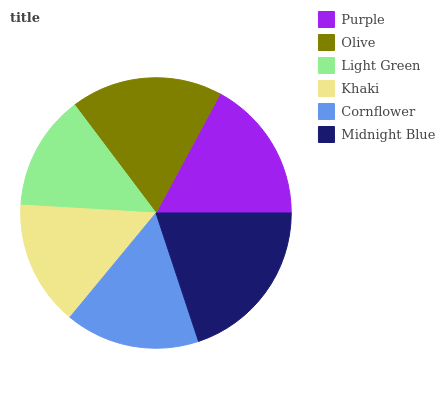Is Light Green the minimum?
Answer yes or no. Yes. Is Midnight Blue the maximum?
Answer yes or no. Yes. Is Olive the minimum?
Answer yes or no. No. Is Olive the maximum?
Answer yes or no. No. Is Olive greater than Purple?
Answer yes or no. Yes. Is Purple less than Olive?
Answer yes or no. Yes. Is Purple greater than Olive?
Answer yes or no. No. Is Olive less than Purple?
Answer yes or no. No. Is Purple the high median?
Answer yes or no. Yes. Is Cornflower the low median?
Answer yes or no. Yes. Is Olive the high median?
Answer yes or no. No. Is Midnight Blue the low median?
Answer yes or no. No. 